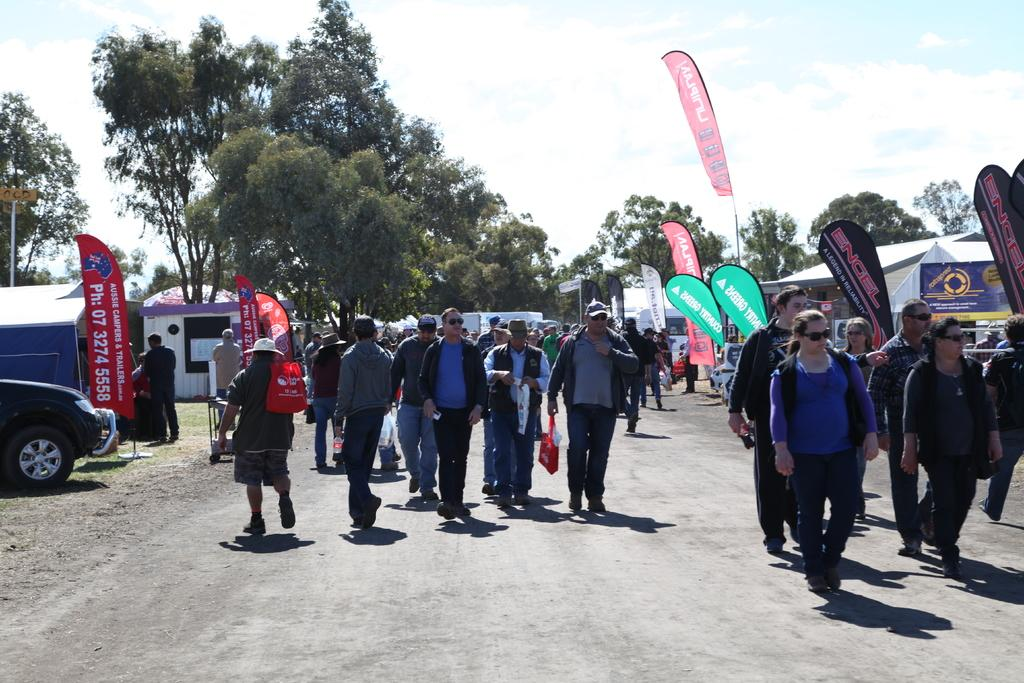What is happening in the image? There is a group of men and women walking on a road. What can be seen in the background of the image? There are trees visible in the background. What type of shops are present on the right side of the image? There are tent shops on the right side of the image. What colors are the flags on the tent shops? The tent shops have red and green color flags. Can you see any pigs running through a stream in the image? No, there are no pigs or streams present in the image. 